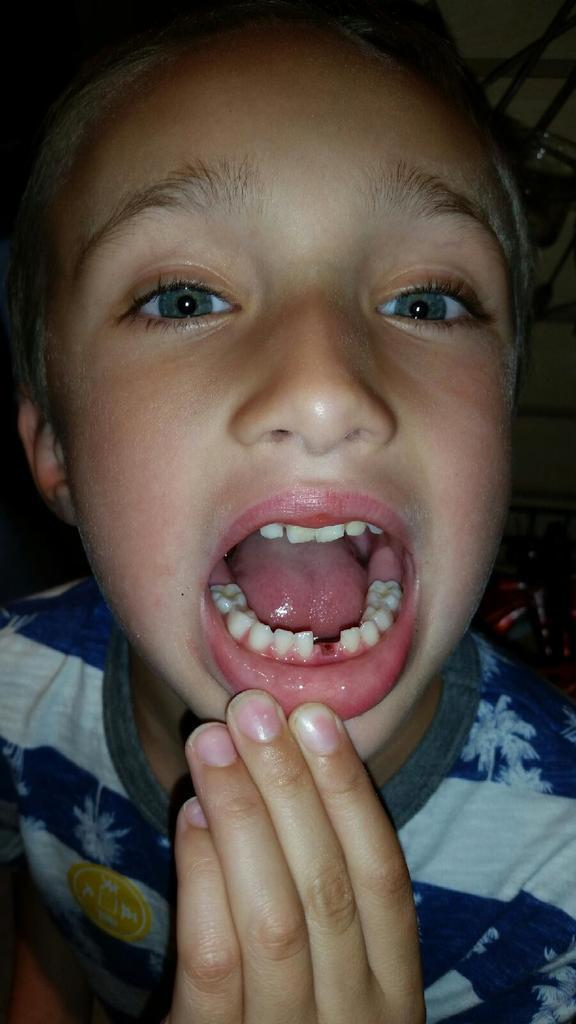What is the main subject of the image? There is a person in the image. Can you describe the person's facial expression or action? The person has an open mouth. What can be seen in the background of the image? There are objects in the background of the image. What type of tax is being discussed in the image? There is no discussion of tax in the image; it features a person with an open mouth and objects in the background. 